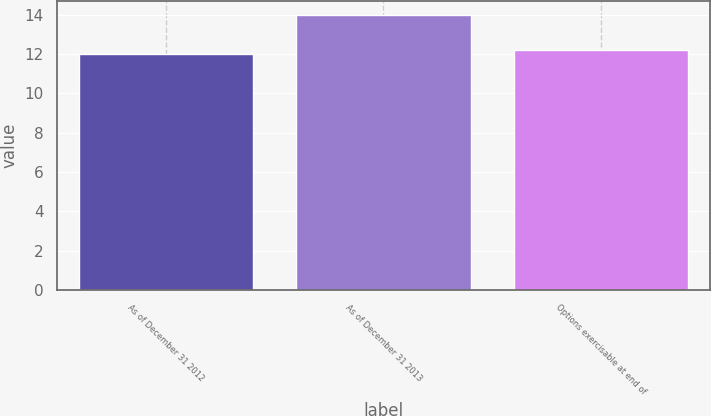<chart> <loc_0><loc_0><loc_500><loc_500><bar_chart><fcel>As of December 31 2012<fcel>As of December 31 2013<fcel>Options exercisable at end of<nl><fcel>12<fcel>14<fcel>12.2<nl></chart> 